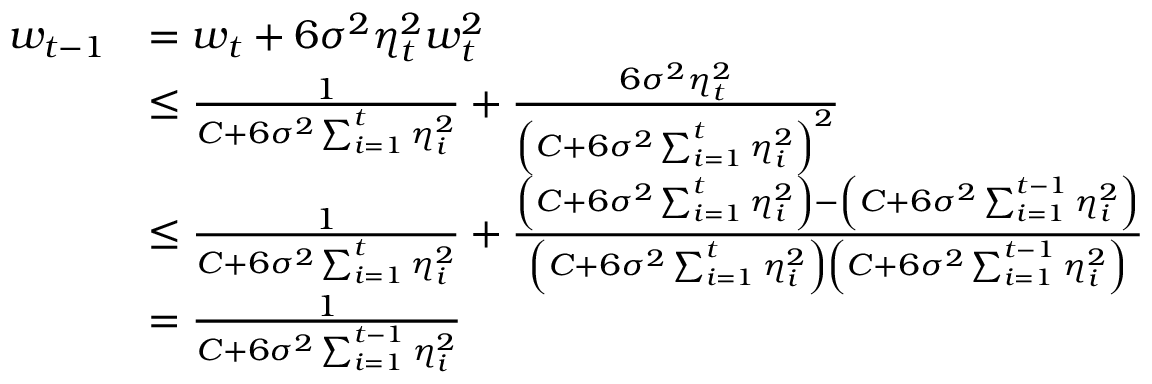<formula> <loc_0><loc_0><loc_500><loc_500>\begin{array} { r l } { w _ { t - 1 } } & { = w _ { t } + 6 \sigma ^ { 2 } \eta _ { t } ^ { 2 } w _ { t } ^ { 2 } } \\ & { \leq \frac { 1 } { C + 6 \sigma ^ { 2 } \sum _ { i = 1 } ^ { t } \eta _ { i } ^ { 2 } } + \frac { 6 \sigma ^ { 2 } \eta _ { t } ^ { 2 } } { \left ( C + 6 \sigma ^ { 2 } \sum _ { i = 1 } ^ { t } \eta _ { i } ^ { 2 } \right ) ^ { 2 } } } \\ & { \leq \frac { 1 } { C + 6 \sigma ^ { 2 } \sum _ { i = 1 } ^ { t } \eta _ { i } ^ { 2 } } + \frac { \left ( C + 6 \sigma ^ { 2 } \sum _ { i = 1 } ^ { t } \eta _ { i } ^ { 2 } \right ) - \left ( C + 6 \sigma ^ { 2 } \sum _ { i = 1 } ^ { t - 1 } \eta _ { i } ^ { 2 } \right ) } { \left ( C + 6 \sigma ^ { 2 } \sum _ { i = 1 } ^ { t } \eta _ { i } ^ { 2 } \right ) \left ( C + 6 \sigma ^ { 2 } \sum _ { i = 1 } ^ { t - 1 } \eta _ { i } ^ { 2 } \right ) } } \\ & { = \frac { 1 } { C + 6 \sigma ^ { 2 } \sum _ { i = 1 } ^ { t - 1 } \eta _ { i } ^ { 2 } } } \end{array}</formula> 